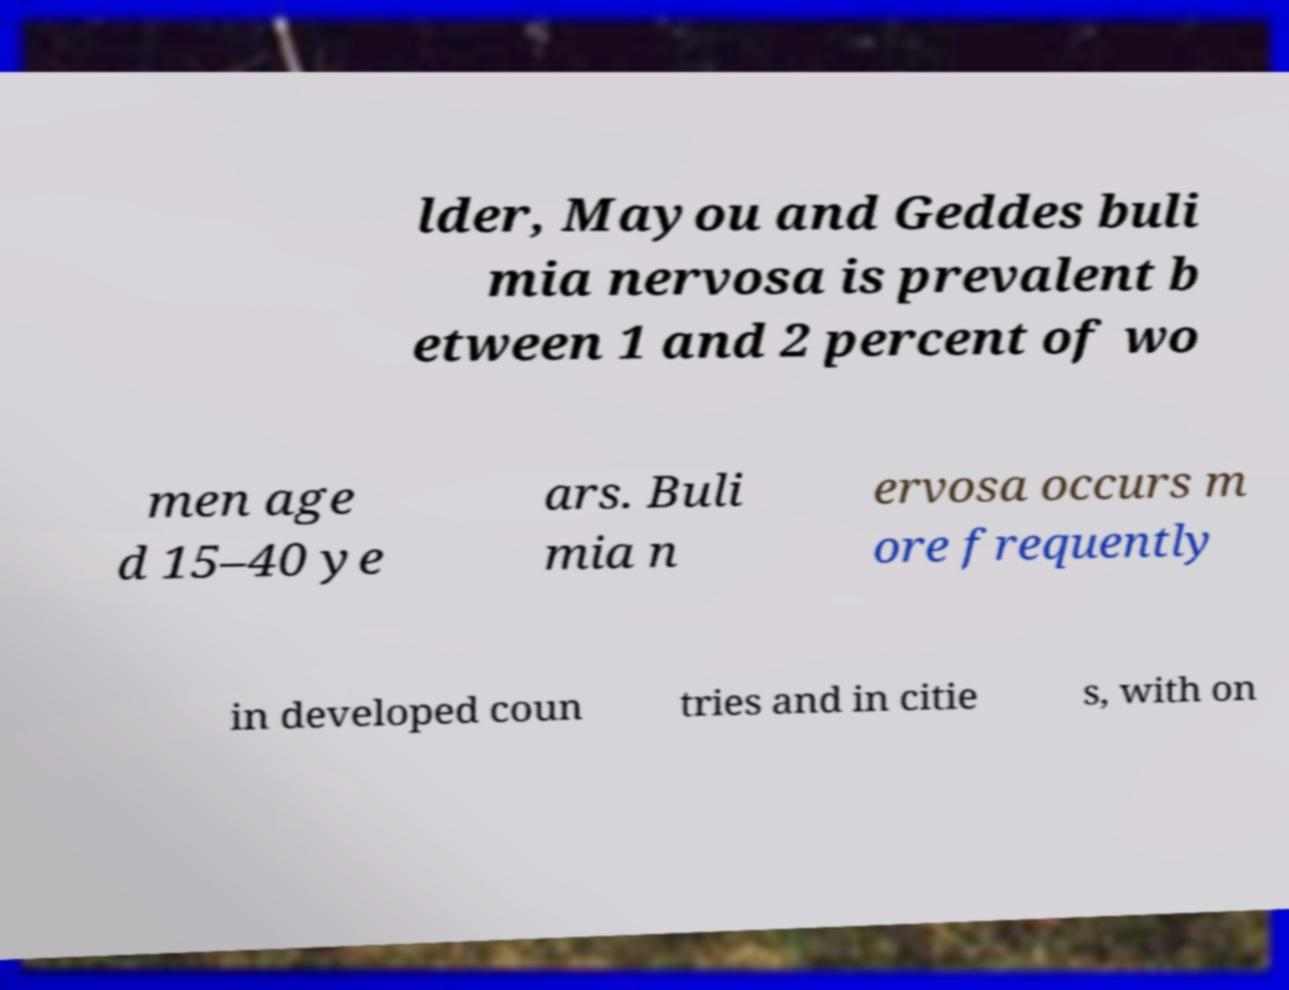There's text embedded in this image that I need extracted. Can you transcribe it verbatim? lder, Mayou and Geddes buli mia nervosa is prevalent b etween 1 and 2 percent of wo men age d 15–40 ye ars. Buli mia n ervosa occurs m ore frequently in developed coun tries and in citie s, with on 